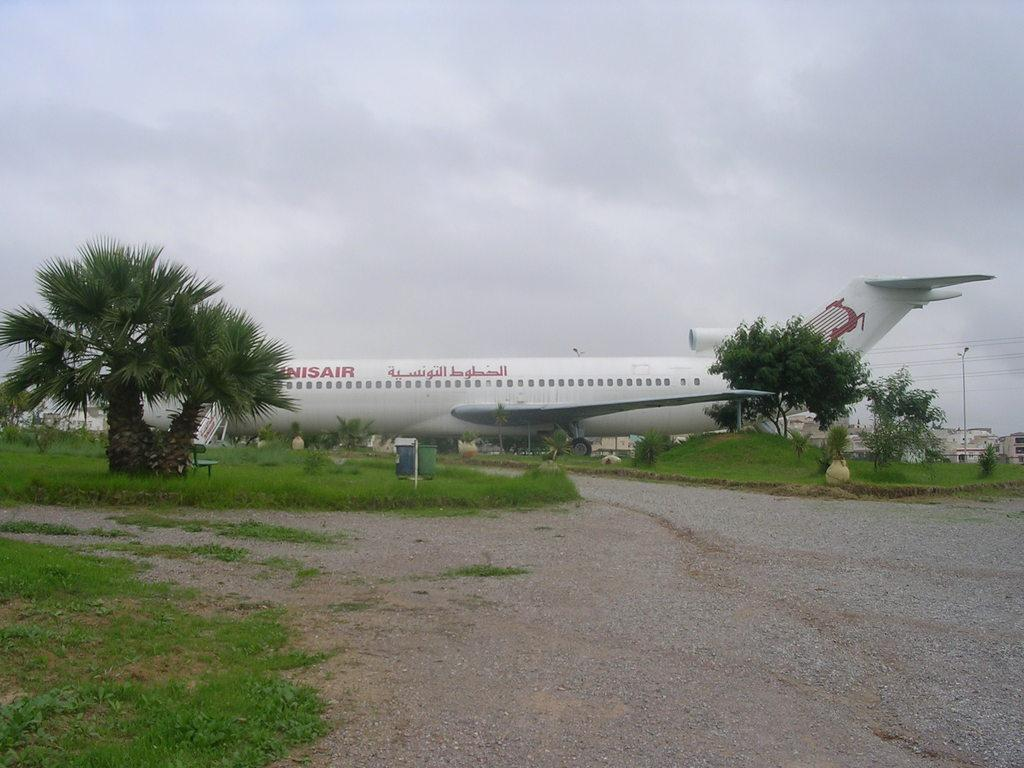What is the main subject of the image? The main subject of the image is an aeroplane. What other objects can be seen in the image besides the aeroplane? There are trees, buildings, a pole, cables, grass, a bench, and other objects on the ground visible in the image. What is the background of the image? The sky is visible in the background of the image. What time of day is it in the image, and can you hear the bells ringing? The time of day cannot be determined from the image, and there are no bells present in the image. 